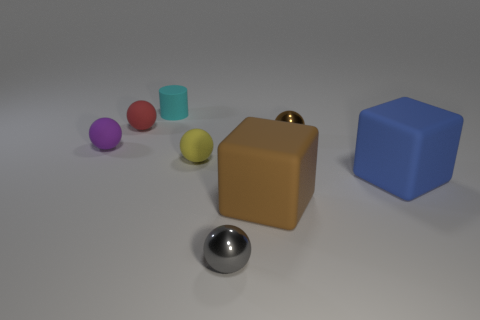Subtract all purple balls. How many balls are left? 4 Subtract all tiny purple matte balls. How many balls are left? 4 Subtract all purple spheres. Subtract all brown blocks. How many spheres are left? 4 Add 2 purple blocks. How many objects exist? 10 Subtract all spheres. How many objects are left? 3 Add 3 cubes. How many cubes exist? 5 Subtract 0 blue cylinders. How many objects are left? 8 Subtract all red things. Subtract all tiny brown balls. How many objects are left? 6 Add 5 big blue rubber things. How many big blue rubber things are left? 6 